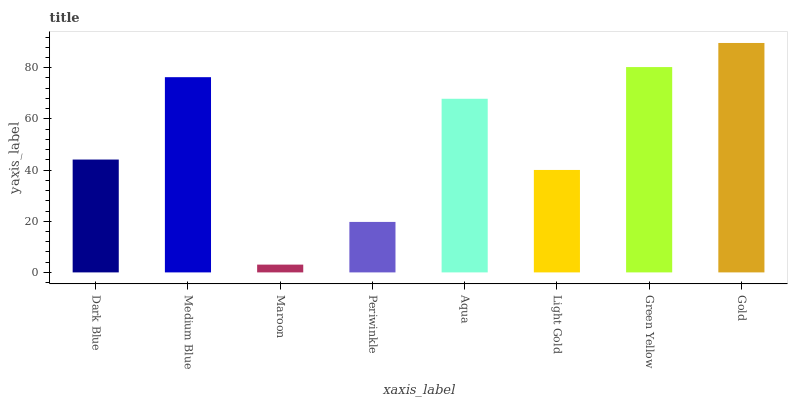Is Maroon the minimum?
Answer yes or no. Yes. Is Gold the maximum?
Answer yes or no. Yes. Is Medium Blue the minimum?
Answer yes or no. No. Is Medium Blue the maximum?
Answer yes or no. No. Is Medium Blue greater than Dark Blue?
Answer yes or no. Yes. Is Dark Blue less than Medium Blue?
Answer yes or no. Yes. Is Dark Blue greater than Medium Blue?
Answer yes or no. No. Is Medium Blue less than Dark Blue?
Answer yes or no. No. Is Aqua the high median?
Answer yes or no. Yes. Is Dark Blue the low median?
Answer yes or no. Yes. Is Light Gold the high median?
Answer yes or no. No. Is Light Gold the low median?
Answer yes or no. No. 